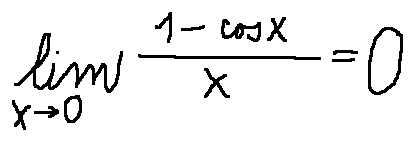Convert formula to latex. <formula><loc_0><loc_0><loc_500><loc_500>\lim \lim i t s _ { x \rightarrow 0 } \frac { 1 - \cos x } { x } = 0</formula> 